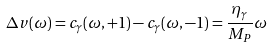Convert formula to latex. <formula><loc_0><loc_0><loc_500><loc_500>\Delta v ( \omega ) = c _ { \gamma } ( \omega , + 1 ) - c _ { \gamma } ( \omega , - 1 ) = \frac { \eta _ { \gamma } } { M _ { P } } \omega</formula> 